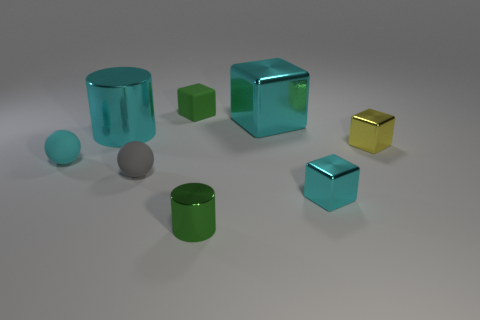Is the number of tiny gray balls left of the gray matte ball less than the number of cyan objects?
Keep it short and to the point. Yes. There is a green object behind the cyan metal cube that is behind the big cyan cylinder; what is its size?
Make the answer very short. Small. What number of objects are big cubes or tiny gray spheres?
Keep it short and to the point. 2. Are there any other shiny blocks of the same color as the big block?
Offer a very short reply. Yes. Is the number of large brown balls less than the number of big cyan metal objects?
Provide a short and direct response. Yes. What number of things are either small cyan matte things or things to the left of the big cyan metallic cube?
Give a very brief answer. 5. Is there a brown ball that has the same material as the yellow object?
Make the answer very short. No. What material is the green cube that is the same size as the gray ball?
Offer a very short reply. Rubber. There is a tiny cyan thing behind the sphere on the right side of the small cyan ball; what is its material?
Offer a very short reply. Rubber. Does the small green thing on the right side of the green block have the same shape as the small yellow object?
Give a very brief answer. No. 